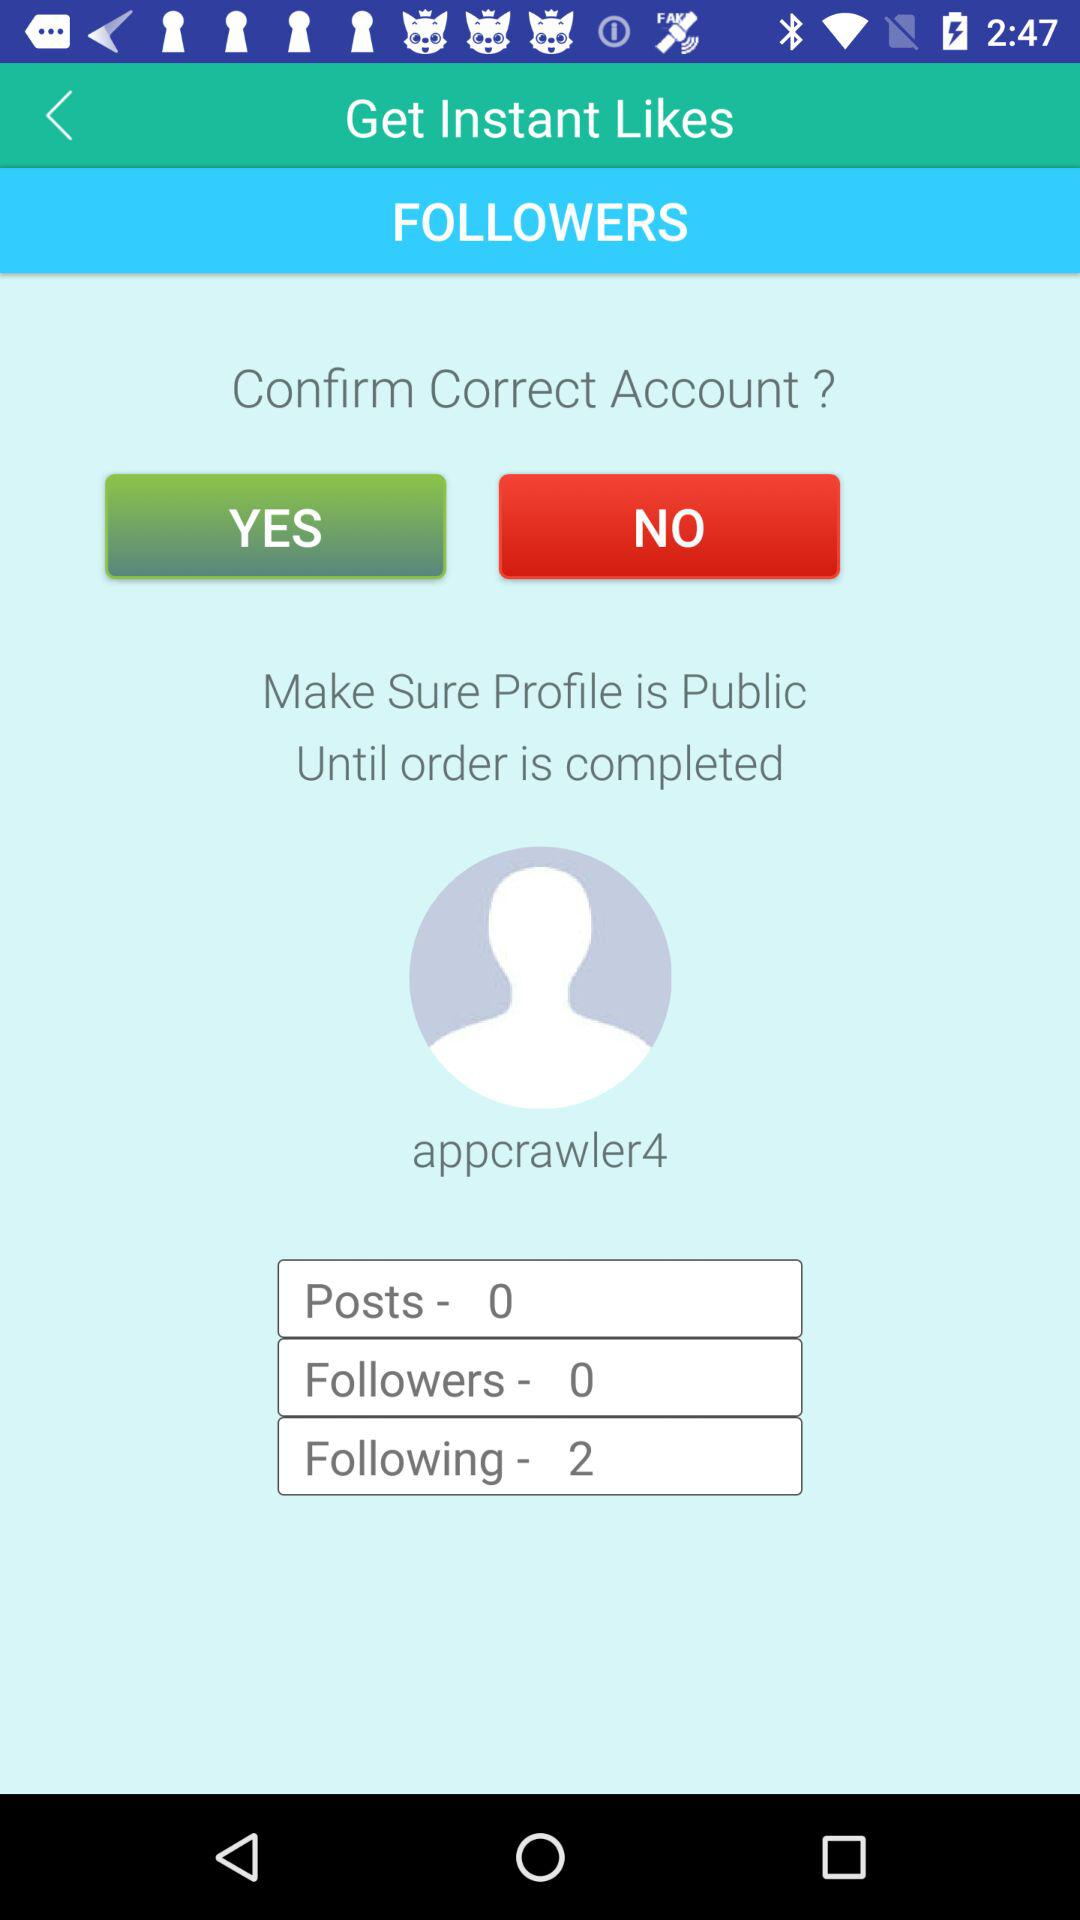What is the application name? The application name is "Get Instant Likes". 